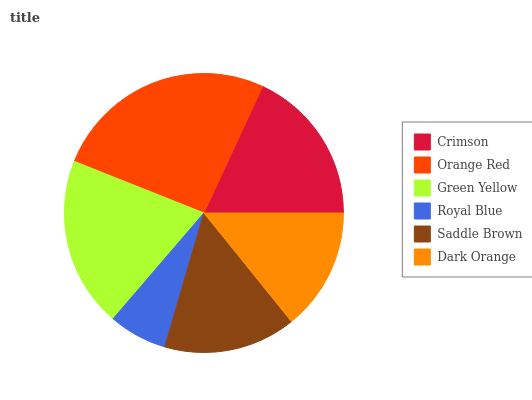Is Royal Blue the minimum?
Answer yes or no. Yes. Is Orange Red the maximum?
Answer yes or no. Yes. Is Green Yellow the minimum?
Answer yes or no. No. Is Green Yellow the maximum?
Answer yes or no. No. Is Orange Red greater than Green Yellow?
Answer yes or no. Yes. Is Green Yellow less than Orange Red?
Answer yes or no. Yes. Is Green Yellow greater than Orange Red?
Answer yes or no. No. Is Orange Red less than Green Yellow?
Answer yes or no. No. Is Crimson the high median?
Answer yes or no. Yes. Is Saddle Brown the low median?
Answer yes or no. Yes. Is Dark Orange the high median?
Answer yes or no. No. Is Green Yellow the low median?
Answer yes or no. No. 